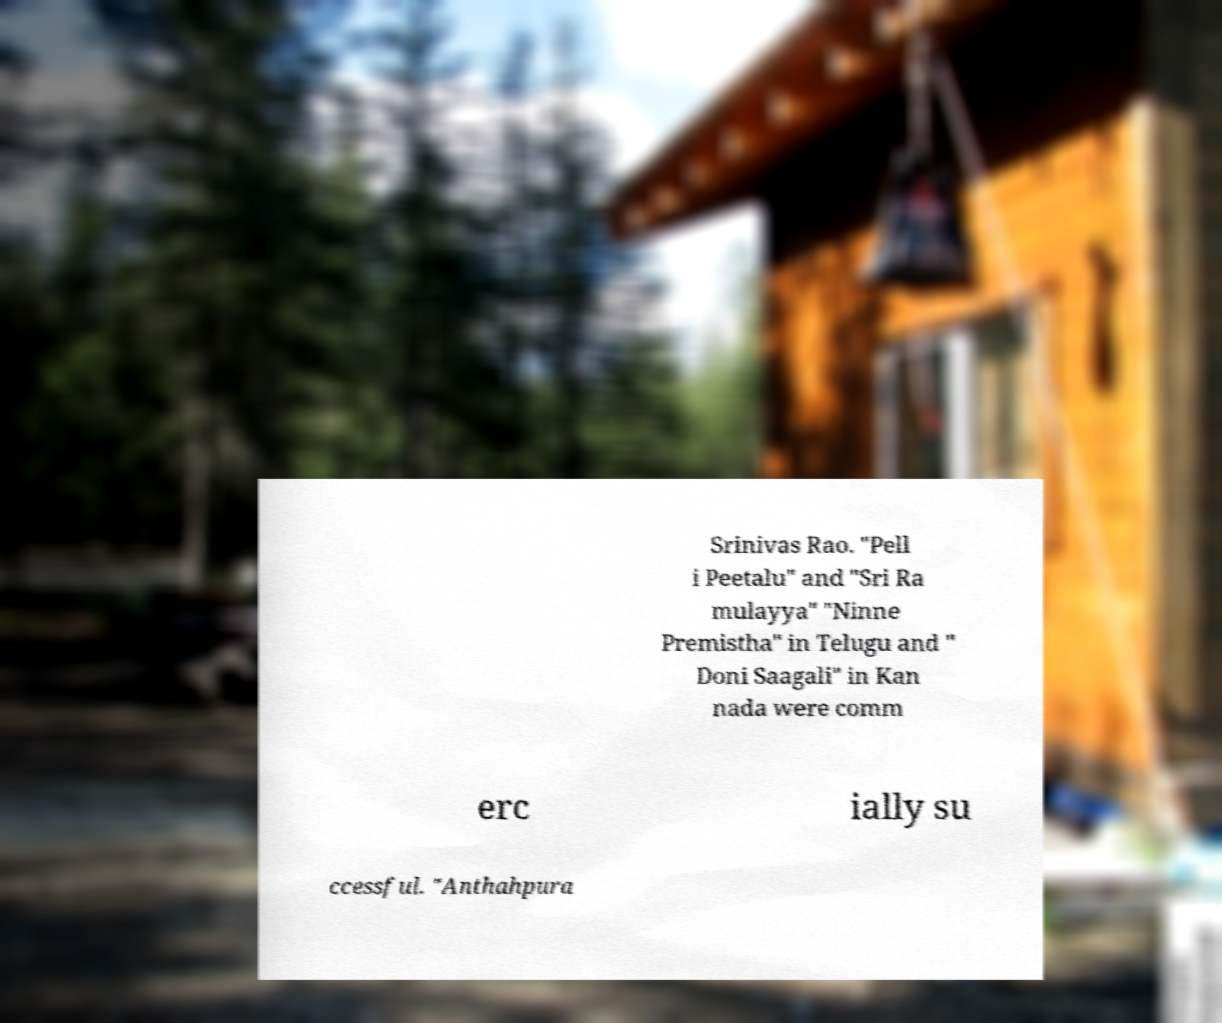For documentation purposes, I need the text within this image transcribed. Could you provide that? Srinivas Rao. "Pell i Peetalu" and "Sri Ra mulayya" "Ninne Premistha" in Telugu and " Doni Saagali" in Kan nada were comm erc ially su ccessful. "Anthahpura 